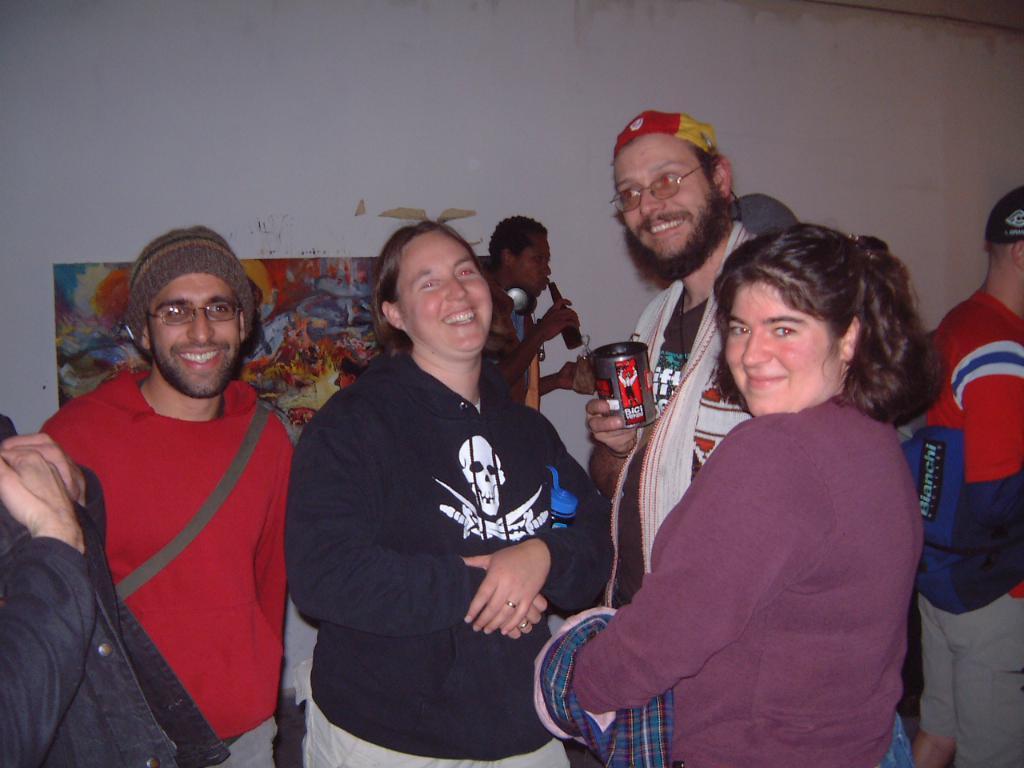In one or two sentences, can you explain what this image depicts? In this picture, we can see a few people, and among them and few are holding some objects, we can see the wall, poster with some art on it. 